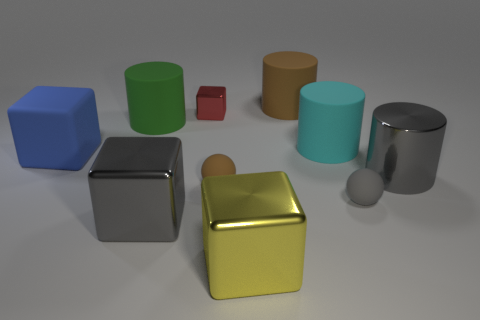Subtract 1 cylinders. How many cylinders are left? 3 Subtract all cubes. How many objects are left? 6 Subtract all tiny gray spheres. Subtract all large objects. How many objects are left? 2 Add 8 small cubes. How many small cubes are left? 9 Add 5 yellow rubber blocks. How many yellow rubber blocks exist? 5 Subtract 0 blue cylinders. How many objects are left? 10 